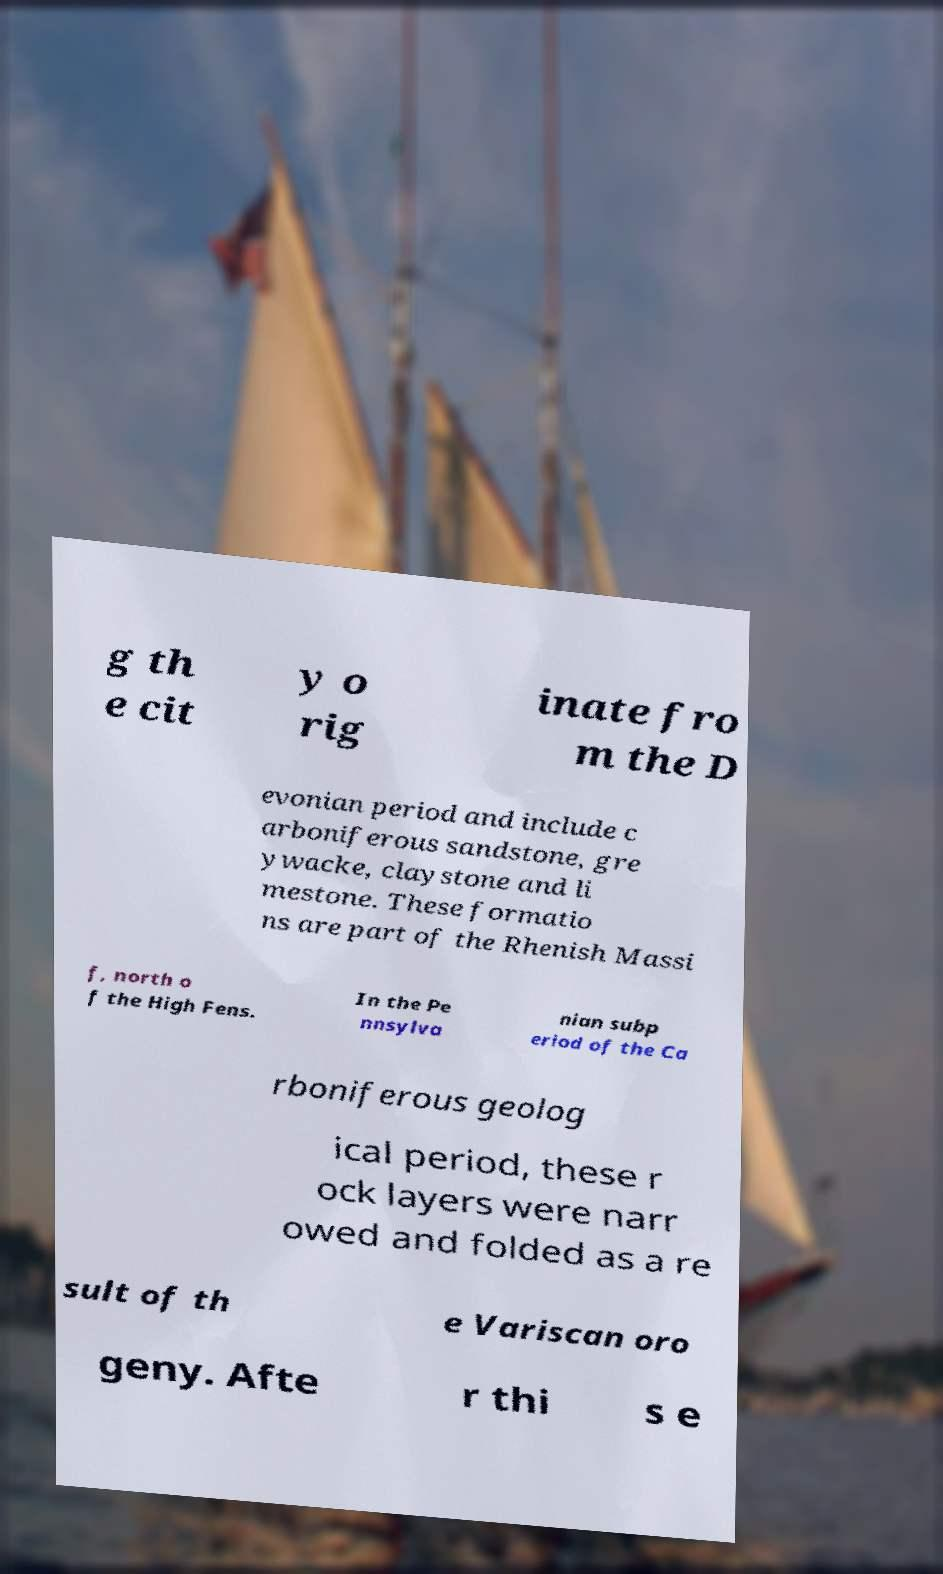For documentation purposes, I need the text within this image transcribed. Could you provide that? g th e cit y o rig inate fro m the D evonian period and include c arboniferous sandstone, gre ywacke, claystone and li mestone. These formatio ns are part of the Rhenish Massi f, north o f the High Fens. In the Pe nnsylva nian subp eriod of the Ca rboniferous geolog ical period, these r ock layers were narr owed and folded as a re sult of th e Variscan oro geny. Afte r thi s e 